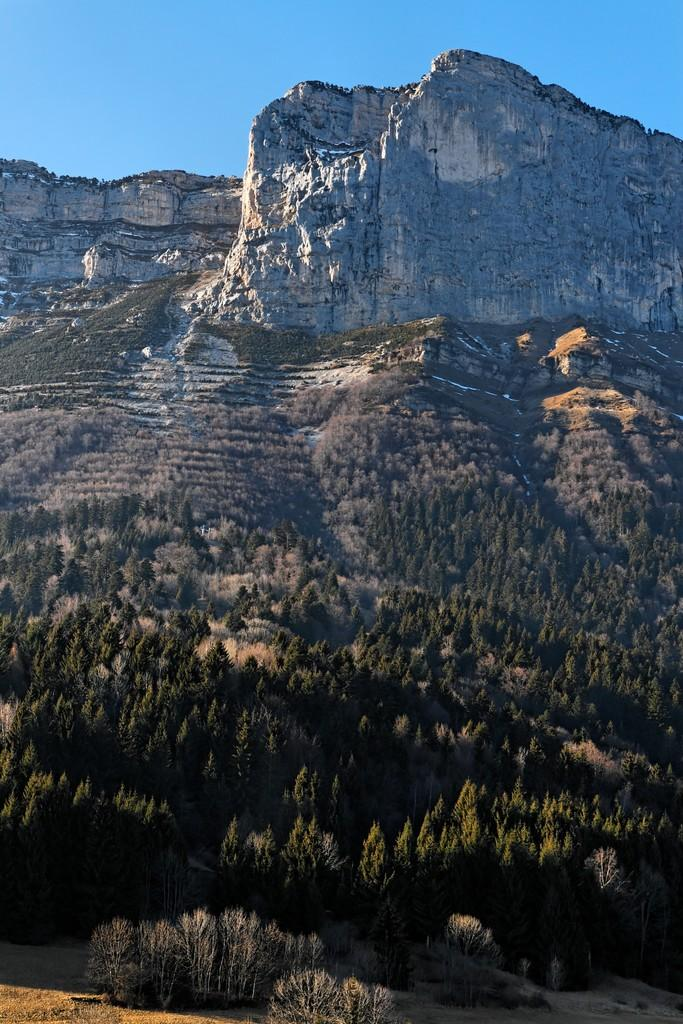What type of vegetation can be seen in the image? There are trees in the image. What type of landscape feature is present in the image? There are hills in the image. What is visible in the background of the image? The sky is visible in the image. Can you tell me how many robins are perched on the trees in the image? There are no robins present in the image; it only features trees and hills. What type of creature is sitting on the kitty in the image? There is no kitty present in the image, as it only features trees and hills. 